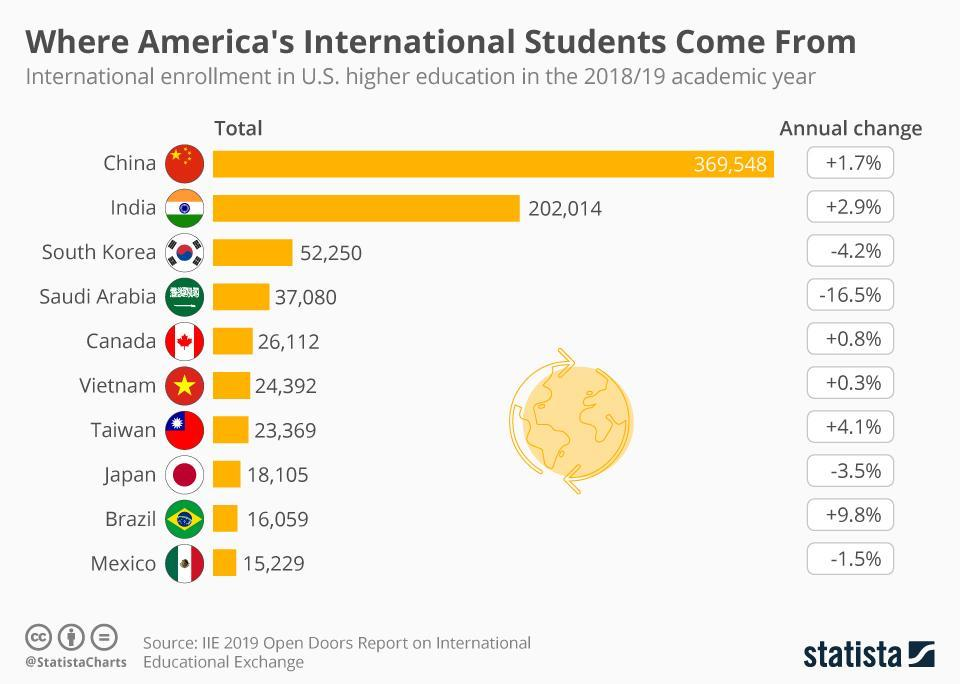Which country has the second-highest no of students to America for higher education?
Answer the question with a short phrase. India From which country a notable decrease in no of students to America for higher education reported? Saudi Arabia How many students are studying in America from India and South Korea took together? 2,54,264 Which country has the highest increase in no of students to America for higher education? Brazil Which country has the second-highest increase in no of students to America for higher education? Taiwan Which country has the fifth-highest no of students to America for higher education? Canada 